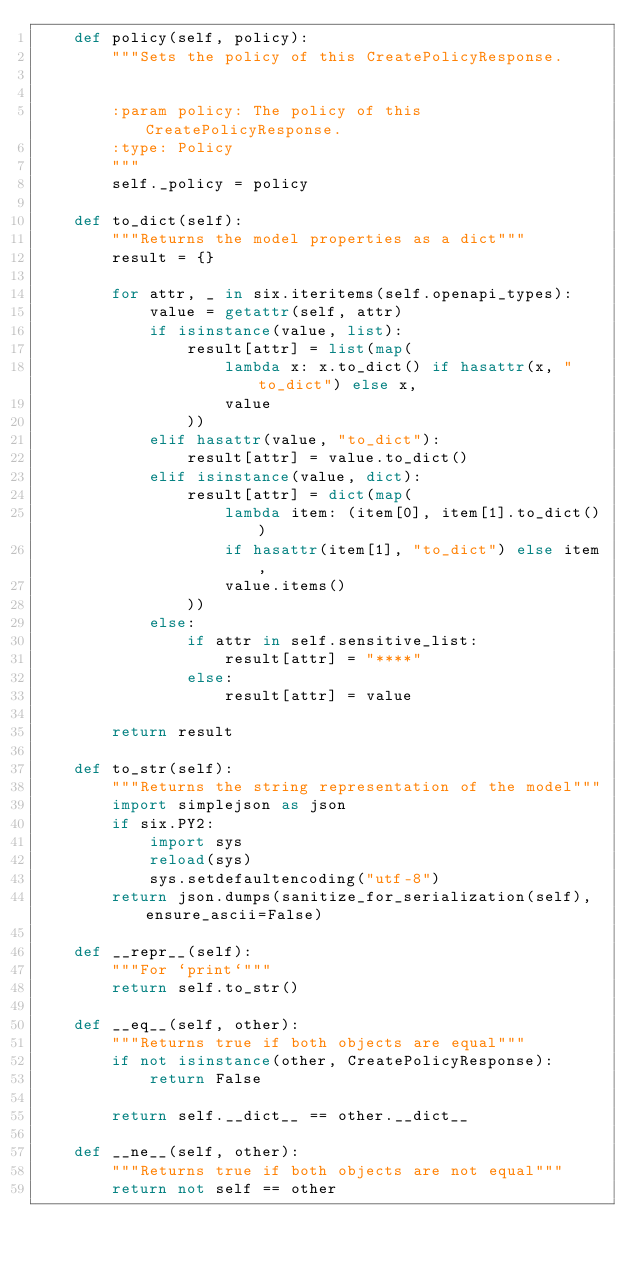Convert code to text. <code><loc_0><loc_0><loc_500><loc_500><_Python_>    def policy(self, policy):
        """Sets the policy of this CreatePolicyResponse.


        :param policy: The policy of this CreatePolicyResponse.
        :type: Policy
        """
        self._policy = policy

    def to_dict(self):
        """Returns the model properties as a dict"""
        result = {}

        for attr, _ in six.iteritems(self.openapi_types):
            value = getattr(self, attr)
            if isinstance(value, list):
                result[attr] = list(map(
                    lambda x: x.to_dict() if hasattr(x, "to_dict") else x,
                    value
                ))
            elif hasattr(value, "to_dict"):
                result[attr] = value.to_dict()
            elif isinstance(value, dict):
                result[attr] = dict(map(
                    lambda item: (item[0], item[1].to_dict())
                    if hasattr(item[1], "to_dict") else item,
                    value.items()
                ))
            else:
                if attr in self.sensitive_list:
                    result[attr] = "****"
                else:
                    result[attr] = value

        return result

    def to_str(self):
        """Returns the string representation of the model"""
        import simplejson as json
        if six.PY2:
            import sys
            reload(sys)
            sys.setdefaultencoding("utf-8")
        return json.dumps(sanitize_for_serialization(self), ensure_ascii=False)

    def __repr__(self):
        """For `print`"""
        return self.to_str()

    def __eq__(self, other):
        """Returns true if both objects are equal"""
        if not isinstance(other, CreatePolicyResponse):
            return False

        return self.__dict__ == other.__dict__

    def __ne__(self, other):
        """Returns true if both objects are not equal"""
        return not self == other
</code> 